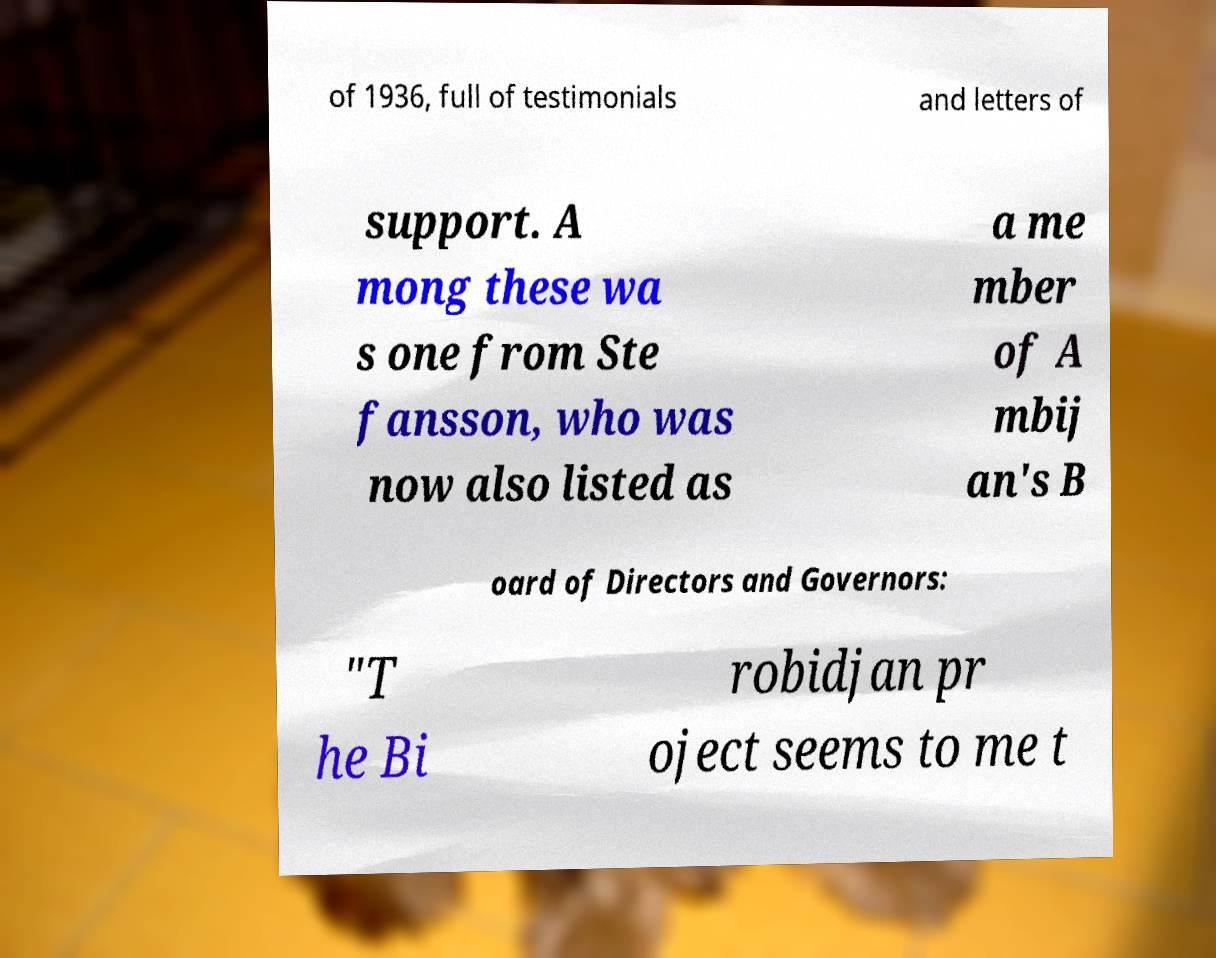There's text embedded in this image that I need extracted. Can you transcribe it verbatim? of 1936, full of testimonials and letters of support. A mong these wa s one from Ste fansson, who was now also listed as a me mber of A mbij an's B oard of Directors and Governors: "T he Bi robidjan pr oject seems to me t 